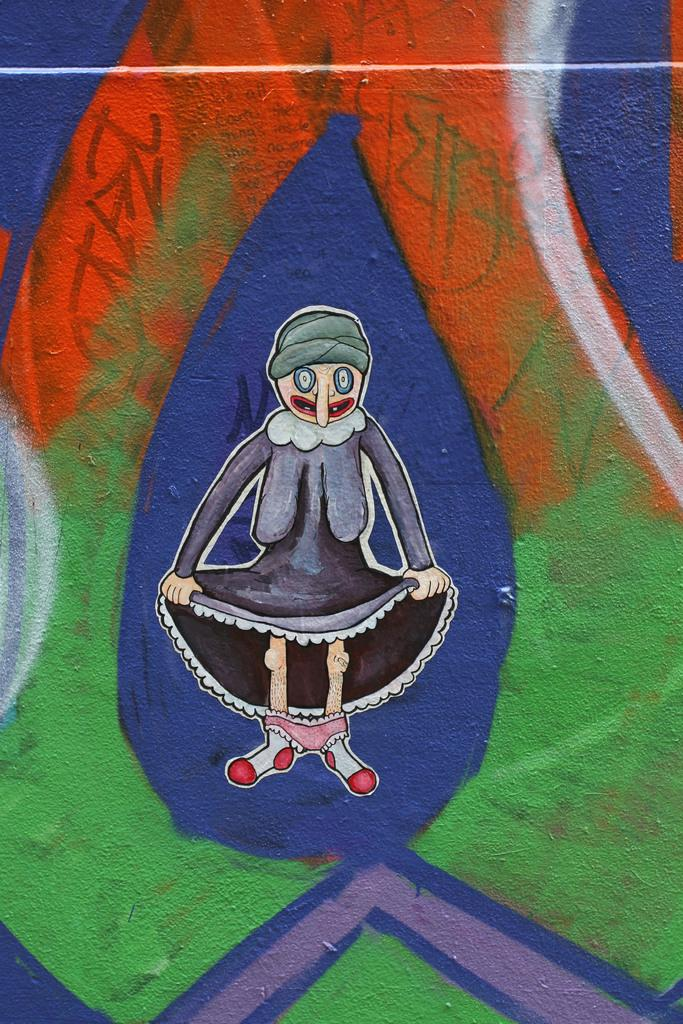What is the main subject of the image? There is a painting in the image. What type of scissors are being used to teach the holiday in the image? There is no reference to teaching, scissors, or a holiday in the image, as it only features a painting. 